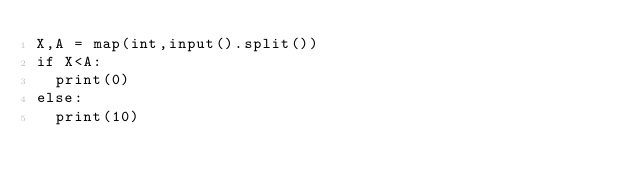Convert code to text. <code><loc_0><loc_0><loc_500><loc_500><_Python_>X,A = map(int,input().split())
if X<A:
  print(0)
else:
  print(10)</code> 